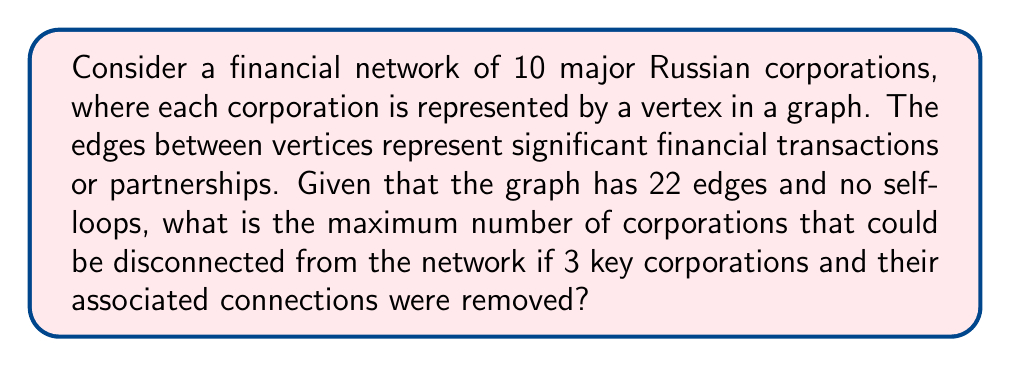Teach me how to tackle this problem. To solve this problem, we'll use concepts from graph theory:

1) First, let's consider the initial graph:
   - Number of vertices (corporations): $n = 10$
   - Number of edges (connections): $m = 22$

2) The maximum number of edges in a complete graph with 10 vertices is:
   $$\binom{10}{2} = \frac{10 \cdot 9}{2} = 45$$

3) This means our graph is not complete and has 45 - 22 = 23 missing edges.

4) When we remove 3 key corporations and their connections, we're removing 3 vertices from the graph. The maximum number of edges these 3 vertices could have had is:
   $$3 \cdot 9 = 27$$ (each could connect to the other 9 vertices)

5) However, we know the total number of edges is only 22. So removing these 3 vertices will remove at most 22 edges.

6) After removal, we're left with 7 vertices. For these to be maximally disconnected, they should have as few edges as possible connecting them.

7) The minimum number of edges needed to connect 7 vertices is 6 (a tree structure). Any fewer and the graph would be disconnected.

8) So, out of the original 22 edges, we need at least 6 to remain among the 7 vertices for them to stay connected.

9) This means we can remove at most 22 - 6 = 16 edges when removing the 3 key corporations.

10) If we remove 16 edges, we're left with 6 edges among 7 vertices. This is exactly enough to form a tree, leaving no extra edges.

11) In a tree with 7 vertices, 6 will be connected and 1 will be disconnected (a leaf node).

Therefore, the maximum number of corporations that could be disconnected is 3 (the ones we removed) + 1 (the leaf node in the remaining tree) = 4.
Answer: 4 corporations 